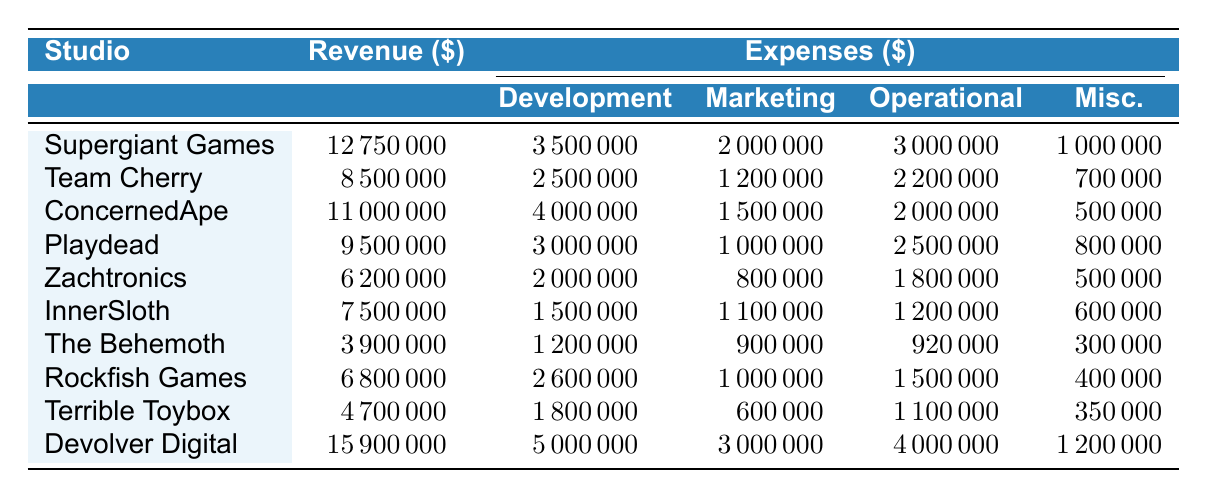What is the revenue of Supergiant Games? The revenue for Supergiant Games is clearly listed in the table. It shows a value of 12,750,000 dollars.
Answer: 12,750,000 Which studio has the highest operational costs? By reviewing the operational costs for each studio, we see that Devolver Digital has 4,000,000 dollars, which is higher than the operational costs of the other studios listed.
Answer: Devolver Digital What is the total revenue of all the studios combined? To find the total revenue, we sum the revenue of each studio: 12,750,000 + 8,500,000 + 11,000,000 + 9,500,000 + 6,200,000 + 7,500,000 + 3,900,000 + 6,800,000 + 4,700,000 + 15,900,000 = 75,850,000.
Answer: 75,850,000 Is the marketing cost for Playdead more than its development cost? Looking at the expenses for Playdead, the development cost is 3,000,000 dollars and the marketing cost is 1,000,000 dollars. Since 1,000,000 is less than 3,000,000, this statement is false.
Answer: No What is the average revenue of the studios located in the USA? The studios in the USA and their revenues are: Supergiant Games (12,750,000), ConcernedApe (11,000,000), Zachtronics (6,200,000), InnerSloth (7,500,000), The Behemoth (3,900,000), Devolver Digital (15,900,000). Adding these gives 57,250,000 and dividing by 6 studios gives an average of 9,541,667.
Answer: 9,541,667 What percentage of total revenue does Team Cherry represent? Team Cherry's revenue is 8,500,000 dollars. The total revenue calculated earlier was 75,850,000. To find the percentage, we take (8,500,000 / 75,850,000) * 100, yielding approximately 11.21 percent.
Answer: 11.21 How much does Terrible Toybox spend on miscellaneous expenses? The table indicates that Terrible Toybox spends 350,000 dollars on miscellaneous expenses.
Answer: 350,000 Is the total expense of Zachtronics greater than the total expense of Playdead? For Zachtronics: 2,000,000 (Development) + 800,000 (Marketing) + 1,800,000 (Operational) + 500,000 (Miscellaneous) totals 5,100,000. For Playdead: 3,000,000 + 1,000,000 + 2,500,000 + 800,000 equals 7,300,000. Since 5,100,000 is less than 7,300,000, this statement is false.
Answer: No What is the difference between the revenue of Devolver Digital and the revenue of The Behemoth? Devolver Digital's revenue is 15,900,000 dollars, and The Behemoth's revenue is 3,900,000 dollars. The difference is 15,900,000 - 3,900,000 = 12,000,000.
Answer: 12,000,000 